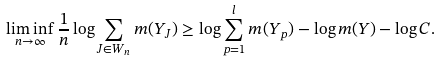Convert formula to latex. <formula><loc_0><loc_0><loc_500><loc_500>\liminf _ { n \to \infty } \frac { 1 } { n } \log \sum _ { J \in W _ { n } } m ( Y _ { J } ) \geq \log \sum _ { p = 1 } ^ { l } m ( Y _ { p } ) - \log m ( Y ) - \log C .</formula> 